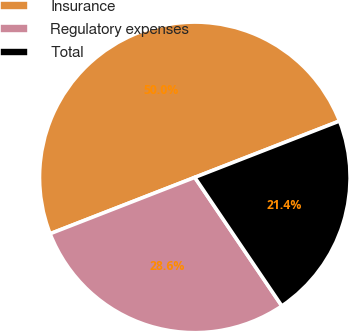Convert chart to OTSL. <chart><loc_0><loc_0><loc_500><loc_500><pie_chart><fcel>Insurance<fcel>Regulatory expenses<fcel>Total<nl><fcel>50.0%<fcel>28.56%<fcel>21.44%<nl></chart> 